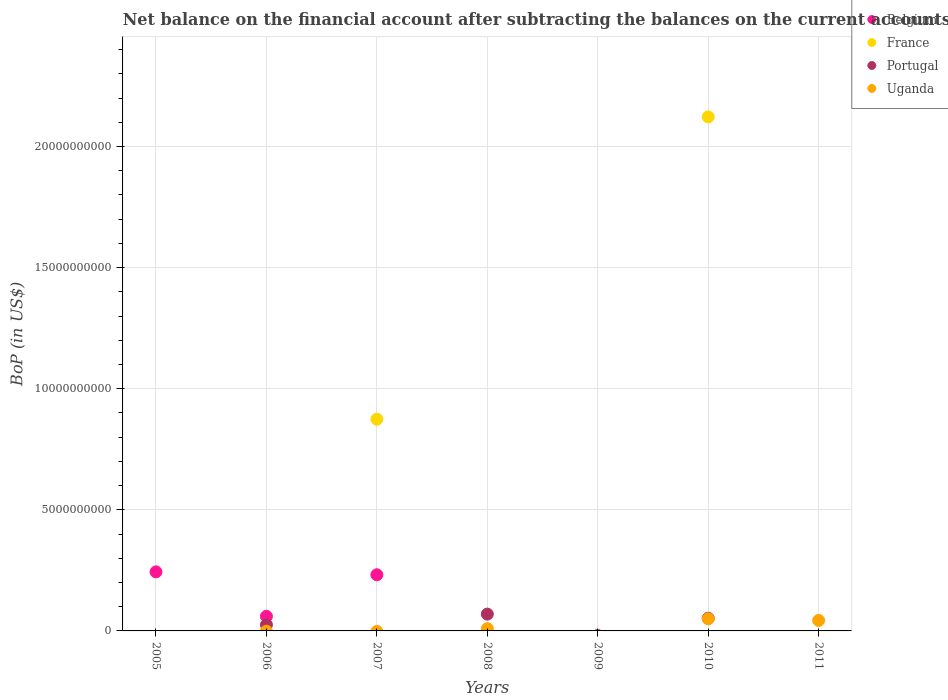How many different coloured dotlines are there?
Make the answer very short. 4. Is the number of dotlines equal to the number of legend labels?
Offer a very short reply. No. What is the Balance of Payments in Belgium in 2008?
Ensure brevity in your answer.  0. Across all years, what is the maximum Balance of Payments in France?
Keep it short and to the point. 2.12e+1. What is the total Balance of Payments in Belgium in the graph?
Your response must be concise. 5.36e+09. What is the difference between the Balance of Payments in France in 2007 and that in 2010?
Offer a terse response. -1.25e+1. What is the average Balance of Payments in Portugal per year?
Your answer should be compact. 2.10e+08. What is the ratio of the Balance of Payments in Belgium in 2005 to that in 2006?
Ensure brevity in your answer.  4.04. What is the difference between the highest and the second highest Balance of Payments in Portugal?
Make the answer very short. 1.69e+08. What is the difference between the highest and the lowest Balance of Payments in Uganda?
Provide a succinct answer. 5.01e+08. Is it the case that in every year, the sum of the Balance of Payments in Portugal and Balance of Payments in Uganda  is greater than the sum of Balance of Payments in Belgium and Balance of Payments in France?
Your answer should be very brief. No. Does the Balance of Payments in Belgium monotonically increase over the years?
Your answer should be very brief. No. Is the Balance of Payments in Uganda strictly less than the Balance of Payments in France over the years?
Give a very brief answer. No. How many years are there in the graph?
Provide a succinct answer. 7. What is the difference between two consecutive major ticks on the Y-axis?
Your answer should be compact. 5.00e+09. Are the values on the major ticks of Y-axis written in scientific E-notation?
Your response must be concise. No. Does the graph contain grids?
Ensure brevity in your answer.  Yes. Where does the legend appear in the graph?
Keep it short and to the point. Top right. How are the legend labels stacked?
Offer a very short reply. Vertical. What is the title of the graph?
Ensure brevity in your answer.  Net balance on the financial account after subtracting the balances on the current accounts. Does "Uruguay" appear as one of the legend labels in the graph?
Your response must be concise. No. What is the label or title of the X-axis?
Keep it short and to the point. Years. What is the label or title of the Y-axis?
Offer a terse response. BoP (in US$). What is the BoP (in US$) of Belgium in 2005?
Provide a succinct answer. 2.44e+09. What is the BoP (in US$) in France in 2005?
Offer a very short reply. 0. What is the BoP (in US$) of Uganda in 2005?
Keep it short and to the point. 0. What is the BoP (in US$) of Belgium in 2006?
Make the answer very short. 6.03e+08. What is the BoP (in US$) in France in 2006?
Offer a terse response. 0. What is the BoP (in US$) in Portugal in 2006?
Keep it short and to the point. 2.53e+08. What is the BoP (in US$) of Uganda in 2006?
Your answer should be very brief. 0. What is the BoP (in US$) in Belgium in 2007?
Make the answer very short. 2.32e+09. What is the BoP (in US$) of France in 2007?
Give a very brief answer. 8.74e+09. What is the BoP (in US$) of Uganda in 2007?
Offer a terse response. 0. What is the BoP (in US$) of France in 2008?
Offer a terse response. 0. What is the BoP (in US$) in Portugal in 2008?
Your response must be concise. 6.94e+08. What is the BoP (in US$) in Uganda in 2008?
Ensure brevity in your answer.  9.07e+07. What is the BoP (in US$) in Belgium in 2009?
Offer a terse response. 0. What is the BoP (in US$) in France in 2009?
Your answer should be very brief. 0. What is the BoP (in US$) in Portugal in 2009?
Make the answer very short. 0. What is the BoP (in US$) in Uganda in 2009?
Ensure brevity in your answer.  0. What is the BoP (in US$) of Belgium in 2010?
Give a very brief answer. 0. What is the BoP (in US$) of France in 2010?
Your answer should be very brief. 2.12e+1. What is the BoP (in US$) in Portugal in 2010?
Provide a succinct answer. 5.25e+08. What is the BoP (in US$) in Uganda in 2010?
Give a very brief answer. 5.01e+08. What is the BoP (in US$) in Belgium in 2011?
Keep it short and to the point. 0. What is the BoP (in US$) in France in 2011?
Give a very brief answer. 0. What is the BoP (in US$) of Uganda in 2011?
Your answer should be compact. 4.33e+08. Across all years, what is the maximum BoP (in US$) in Belgium?
Keep it short and to the point. 2.44e+09. Across all years, what is the maximum BoP (in US$) of France?
Make the answer very short. 2.12e+1. Across all years, what is the maximum BoP (in US$) of Portugal?
Provide a succinct answer. 6.94e+08. Across all years, what is the maximum BoP (in US$) of Uganda?
Provide a short and direct response. 5.01e+08. Across all years, what is the minimum BoP (in US$) of Belgium?
Provide a short and direct response. 0. Across all years, what is the minimum BoP (in US$) of Portugal?
Provide a short and direct response. 0. Across all years, what is the minimum BoP (in US$) of Uganda?
Ensure brevity in your answer.  0. What is the total BoP (in US$) of Belgium in the graph?
Keep it short and to the point. 5.36e+09. What is the total BoP (in US$) in France in the graph?
Provide a succinct answer. 3.00e+1. What is the total BoP (in US$) of Portugal in the graph?
Your answer should be compact. 1.47e+09. What is the total BoP (in US$) of Uganda in the graph?
Give a very brief answer. 1.03e+09. What is the difference between the BoP (in US$) of Belgium in 2005 and that in 2006?
Your response must be concise. 1.84e+09. What is the difference between the BoP (in US$) of Belgium in 2005 and that in 2007?
Offer a terse response. 1.20e+08. What is the difference between the BoP (in US$) of Belgium in 2006 and that in 2007?
Ensure brevity in your answer.  -1.72e+09. What is the difference between the BoP (in US$) of Portugal in 2006 and that in 2008?
Provide a succinct answer. -4.41e+08. What is the difference between the BoP (in US$) of Portugal in 2006 and that in 2010?
Give a very brief answer. -2.72e+08. What is the difference between the BoP (in US$) in France in 2007 and that in 2010?
Offer a terse response. -1.25e+1. What is the difference between the BoP (in US$) in Portugal in 2008 and that in 2010?
Provide a short and direct response. 1.69e+08. What is the difference between the BoP (in US$) of Uganda in 2008 and that in 2010?
Ensure brevity in your answer.  -4.11e+08. What is the difference between the BoP (in US$) in Uganda in 2008 and that in 2011?
Your response must be concise. -3.43e+08. What is the difference between the BoP (in US$) of Uganda in 2010 and that in 2011?
Ensure brevity in your answer.  6.79e+07. What is the difference between the BoP (in US$) in Belgium in 2005 and the BoP (in US$) in Portugal in 2006?
Your answer should be compact. 2.19e+09. What is the difference between the BoP (in US$) of Belgium in 2005 and the BoP (in US$) of France in 2007?
Offer a terse response. -6.30e+09. What is the difference between the BoP (in US$) in Belgium in 2005 and the BoP (in US$) in Portugal in 2008?
Make the answer very short. 1.74e+09. What is the difference between the BoP (in US$) in Belgium in 2005 and the BoP (in US$) in Uganda in 2008?
Offer a very short reply. 2.35e+09. What is the difference between the BoP (in US$) in Belgium in 2005 and the BoP (in US$) in France in 2010?
Keep it short and to the point. -1.88e+1. What is the difference between the BoP (in US$) of Belgium in 2005 and the BoP (in US$) of Portugal in 2010?
Offer a very short reply. 1.91e+09. What is the difference between the BoP (in US$) of Belgium in 2005 and the BoP (in US$) of Uganda in 2010?
Give a very brief answer. 1.94e+09. What is the difference between the BoP (in US$) in Belgium in 2005 and the BoP (in US$) in Uganda in 2011?
Offer a very short reply. 2.01e+09. What is the difference between the BoP (in US$) in Belgium in 2006 and the BoP (in US$) in France in 2007?
Provide a succinct answer. -8.14e+09. What is the difference between the BoP (in US$) in Belgium in 2006 and the BoP (in US$) in Portugal in 2008?
Provide a succinct answer. -9.10e+07. What is the difference between the BoP (in US$) of Belgium in 2006 and the BoP (in US$) of Uganda in 2008?
Give a very brief answer. 5.13e+08. What is the difference between the BoP (in US$) of Portugal in 2006 and the BoP (in US$) of Uganda in 2008?
Ensure brevity in your answer.  1.63e+08. What is the difference between the BoP (in US$) of Belgium in 2006 and the BoP (in US$) of France in 2010?
Offer a very short reply. -2.06e+1. What is the difference between the BoP (in US$) of Belgium in 2006 and the BoP (in US$) of Portugal in 2010?
Provide a succinct answer. 7.80e+07. What is the difference between the BoP (in US$) in Belgium in 2006 and the BoP (in US$) in Uganda in 2010?
Your answer should be very brief. 1.02e+08. What is the difference between the BoP (in US$) of Portugal in 2006 and the BoP (in US$) of Uganda in 2010?
Provide a short and direct response. -2.48e+08. What is the difference between the BoP (in US$) of Belgium in 2006 and the BoP (in US$) of Uganda in 2011?
Provide a succinct answer. 1.70e+08. What is the difference between the BoP (in US$) of Portugal in 2006 and the BoP (in US$) of Uganda in 2011?
Keep it short and to the point. -1.80e+08. What is the difference between the BoP (in US$) of Belgium in 2007 and the BoP (in US$) of Portugal in 2008?
Your answer should be compact. 1.62e+09. What is the difference between the BoP (in US$) of Belgium in 2007 and the BoP (in US$) of Uganda in 2008?
Your answer should be very brief. 2.23e+09. What is the difference between the BoP (in US$) of France in 2007 and the BoP (in US$) of Portugal in 2008?
Provide a succinct answer. 8.05e+09. What is the difference between the BoP (in US$) in France in 2007 and the BoP (in US$) in Uganda in 2008?
Your answer should be very brief. 8.65e+09. What is the difference between the BoP (in US$) of Belgium in 2007 and the BoP (in US$) of France in 2010?
Your answer should be compact. -1.89e+1. What is the difference between the BoP (in US$) of Belgium in 2007 and the BoP (in US$) of Portugal in 2010?
Make the answer very short. 1.79e+09. What is the difference between the BoP (in US$) in Belgium in 2007 and the BoP (in US$) in Uganda in 2010?
Provide a succinct answer. 1.82e+09. What is the difference between the BoP (in US$) in France in 2007 and the BoP (in US$) in Portugal in 2010?
Your answer should be compact. 8.22e+09. What is the difference between the BoP (in US$) of France in 2007 and the BoP (in US$) of Uganda in 2010?
Offer a very short reply. 8.24e+09. What is the difference between the BoP (in US$) in Belgium in 2007 and the BoP (in US$) in Uganda in 2011?
Ensure brevity in your answer.  1.89e+09. What is the difference between the BoP (in US$) of France in 2007 and the BoP (in US$) of Uganda in 2011?
Provide a succinct answer. 8.31e+09. What is the difference between the BoP (in US$) of Portugal in 2008 and the BoP (in US$) of Uganda in 2010?
Your answer should be very brief. 1.93e+08. What is the difference between the BoP (in US$) in Portugal in 2008 and the BoP (in US$) in Uganda in 2011?
Give a very brief answer. 2.61e+08. What is the difference between the BoP (in US$) of France in 2010 and the BoP (in US$) of Uganda in 2011?
Keep it short and to the point. 2.08e+1. What is the difference between the BoP (in US$) in Portugal in 2010 and the BoP (in US$) in Uganda in 2011?
Provide a short and direct response. 9.20e+07. What is the average BoP (in US$) in Belgium per year?
Give a very brief answer. 7.66e+08. What is the average BoP (in US$) of France per year?
Offer a terse response. 4.28e+09. What is the average BoP (in US$) in Portugal per year?
Your answer should be compact. 2.10e+08. What is the average BoP (in US$) in Uganda per year?
Keep it short and to the point. 1.46e+08. In the year 2006, what is the difference between the BoP (in US$) in Belgium and BoP (in US$) in Portugal?
Your response must be concise. 3.50e+08. In the year 2007, what is the difference between the BoP (in US$) in Belgium and BoP (in US$) in France?
Provide a short and direct response. -6.42e+09. In the year 2008, what is the difference between the BoP (in US$) of Portugal and BoP (in US$) of Uganda?
Provide a short and direct response. 6.04e+08. In the year 2010, what is the difference between the BoP (in US$) in France and BoP (in US$) in Portugal?
Your answer should be compact. 2.07e+1. In the year 2010, what is the difference between the BoP (in US$) of France and BoP (in US$) of Uganda?
Make the answer very short. 2.07e+1. In the year 2010, what is the difference between the BoP (in US$) of Portugal and BoP (in US$) of Uganda?
Your answer should be compact. 2.41e+07. What is the ratio of the BoP (in US$) of Belgium in 2005 to that in 2006?
Offer a very short reply. 4.04. What is the ratio of the BoP (in US$) of Belgium in 2005 to that in 2007?
Your answer should be very brief. 1.05. What is the ratio of the BoP (in US$) in Belgium in 2006 to that in 2007?
Your answer should be compact. 0.26. What is the ratio of the BoP (in US$) of Portugal in 2006 to that in 2008?
Offer a terse response. 0.36. What is the ratio of the BoP (in US$) of Portugal in 2006 to that in 2010?
Give a very brief answer. 0.48. What is the ratio of the BoP (in US$) of France in 2007 to that in 2010?
Make the answer very short. 0.41. What is the ratio of the BoP (in US$) in Portugal in 2008 to that in 2010?
Provide a short and direct response. 1.32. What is the ratio of the BoP (in US$) in Uganda in 2008 to that in 2010?
Your answer should be very brief. 0.18. What is the ratio of the BoP (in US$) of Uganda in 2008 to that in 2011?
Your answer should be compact. 0.21. What is the ratio of the BoP (in US$) of Uganda in 2010 to that in 2011?
Provide a succinct answer. 1.16. What is the difference between the highest and the second highest BoP (in US$) in Belgium?
Give a very brief answer. 1.20e+08. What is the difference between the highest and the second highest BoP (in US$) in Portugal?
Keep it short and to the point. 1.69e+08. What is the difference between the highest and the second highest BoP (in US$) of Uganda?
Offer a terse response. 6.79e+07. What is the difference between the highest and the lowest BoP (in US$) in Belgium?
Make the answer very short. 2.44e+09. What is the difference between the highest and the lowest BoP (in US$) in France?
Offer a terse response. 2.12e+1. What is the difference between the highest and the lowest BoP (in US$) of Portugal?
Provide a short and direct response. 6.94e+08. What is the difference between the highest and the lowest BoP (in US$) of Uganda?
Ensure brevity in your answer.  5.01e+08. 